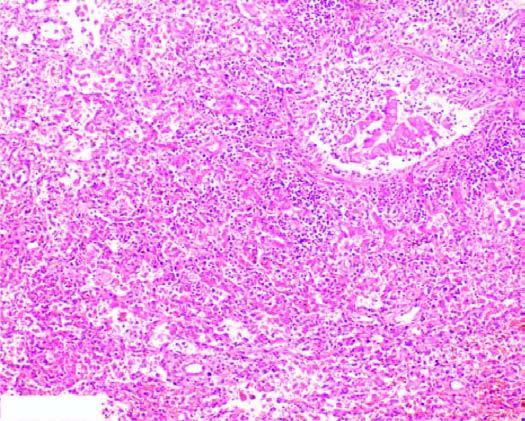re these cases filled with exudate consisting chiefly of neutrophils?
Answer the question using a single word or phrase. No 